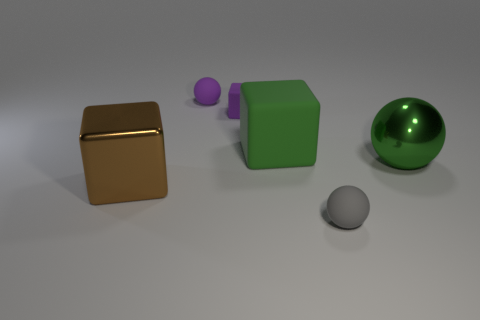What number of other objects are there of the same shape as the small gray rubber object?
Provide a short and direct response. 2. How big is the thing that is on the left side of the small ball that is behind the small rubber sphere that is in front of the large metallic block?
Provide a succinct answer. Large. How many gray things are either metal spheres or tiny shiny things?
Offer a terse response. 0. What is the shape of the metallic thing on the right side of the sphere that is in front of the big metallic cube?
Offer a very short reply. Sphere. Does the matte thing in front of the big green ball have the same size as the green object in front of the green matte object?
Keep it short and to the point. No. Are there any tiny objects made of the same material as the purple ball?
Make the answer very short. Yes. There is a metallic ball that is the same color as the big rubber block; what is its size?
Your answer should be compact. Large. There is a tiny cube that is behind the tiny matte ball that is in front of the big brown block; is there a gray ball behind it?
Provide a succinct answer. No. There is a big green block; are there any large blocks in front of it?
Ensure brevity in your answer.  Yes. How many tiny purple things are on the left side of the big thing that is behind the green sphere?
Give a very brief answer. 2. 